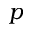<formula> <loc_0><loc_0><loc_500><loc_500>p</formula> 